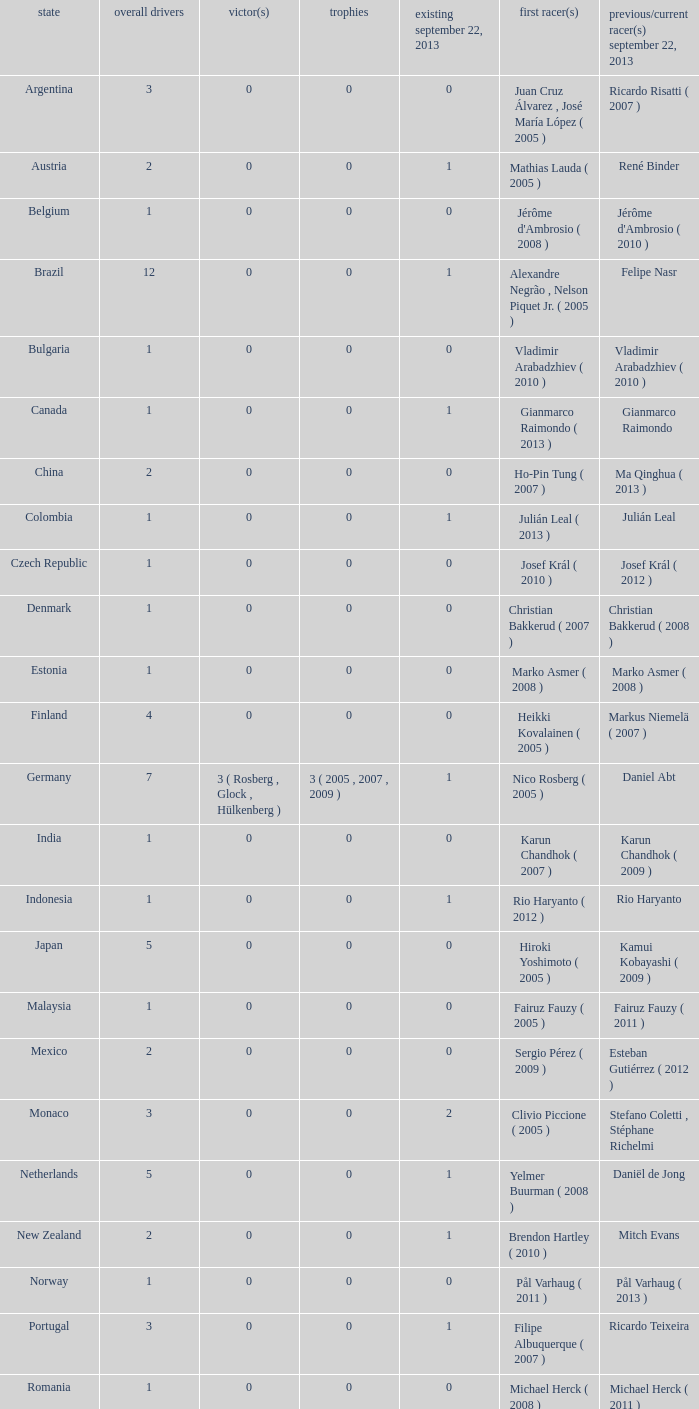How many champions were there when the first driver was hiroki yoshimoto ( 2005 )? 0.0. 